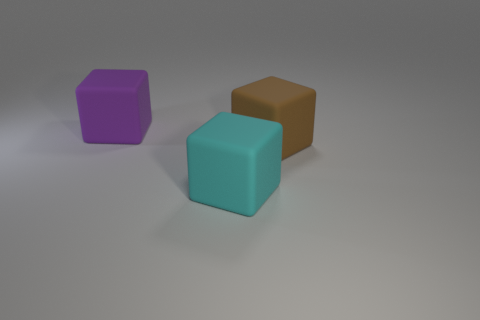Add 2 big green cubes. How many objects exist? 5 Add 3 large cyan matte cubes. How many large cyan matte cubes are left? 4 Add 1 big cyan objects. How many big cyan objects exist? 2 Subtract 0 yellow spheres. How many objects are left? 3 Subtract all big matte blocks. Subtract all big rubber spheres. How many objects are left? 0 